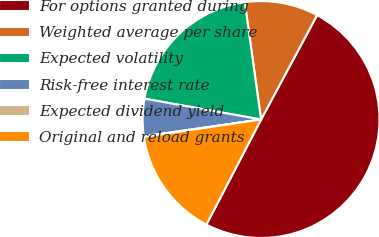Convert chart to OTSL. <chart><loc_0><loc_0><loc_500><loc_500><pie_chart><fcel>For options granted during<fcel>Weighted average per share<fcel>Expected volatility<fcel>Risk-free interest rate<fcel>Expected dividend yield<fcel>Original and reload grants<nl><fcel>49.8%<fcel>10.04%<fcel>19.98%<fcel>5.07%<fcel>0.1%<fcel>15.01%<nl></chart> 